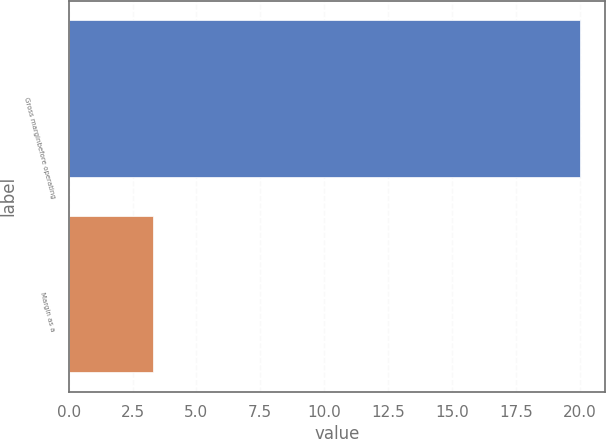<chart> <loc_0><loc_0><loc_500><loc_500><bar_chart><fcel>Gross marginbefore operating<fcel>Margin as a<nl><fcel>20<fcel>3.3<nl></chart> 